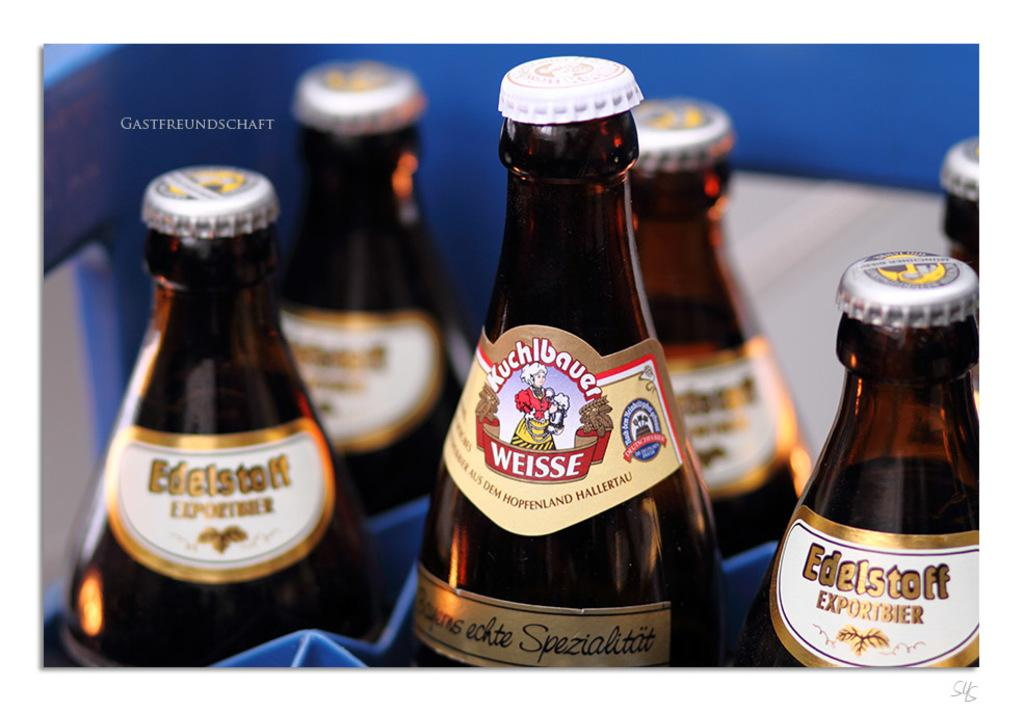What objects are present in the image? There are bottles in the image. What feature do the bottles have? The bottles have caps and labels. How are the bottles arranged in the image? The bottles are kept in a tray. What type of disease is being treated by the bottles in the image? There is no indication of any disease or medical treatment in the image; it simply shows bottles with caps and labels. 